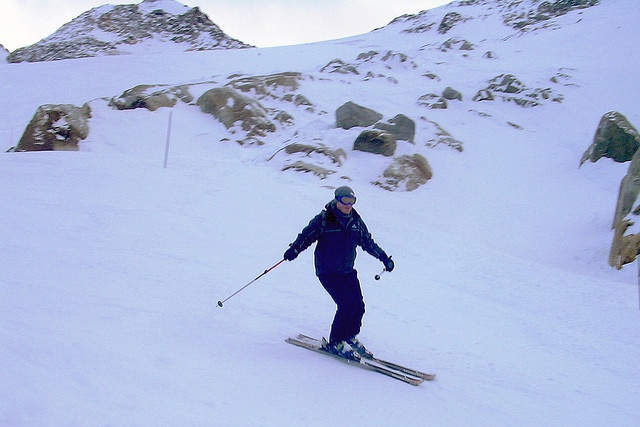Describe the objects in this image and their specific colors. I can see people in white, navy, lavender, and gray tones and skis in white, gray, and navy tones in this image. 